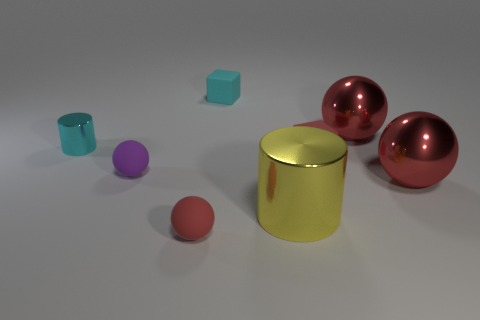What shape is the red metal thing that is in front of the cylinder behind the big cylinder? The red metal object in front of the smaller cylinder and behind the larger cylinder is not a sphere; it appears to be a cap-shaped object, likely a hemisphere, with a flat circular base and a dome-like top. 